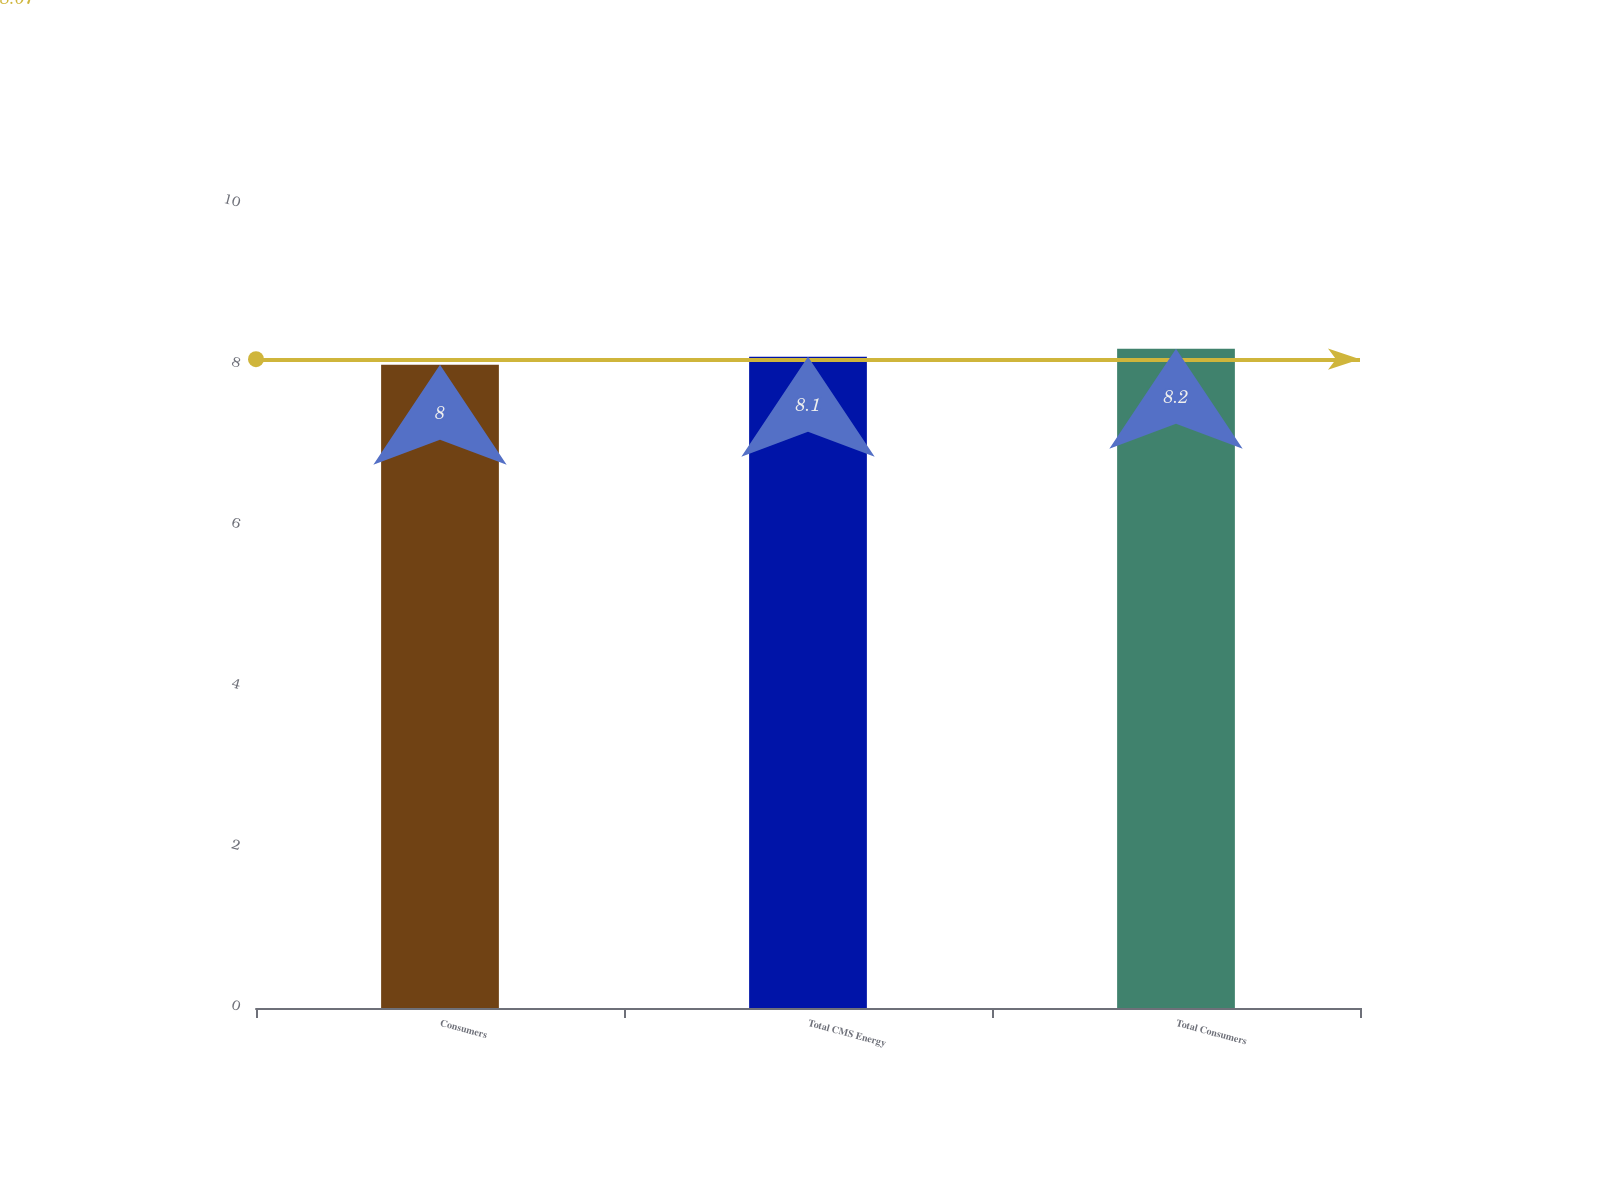Convert chart. <chart><loc_0><loc_0><loc_500><loc_500><bar_chart><fcel>Consumers<fcel>Total CMS Energy<fcel>Total Consumers<nl><fcel>8<fcel>8.1<fcel>8.2<nl></chart> 